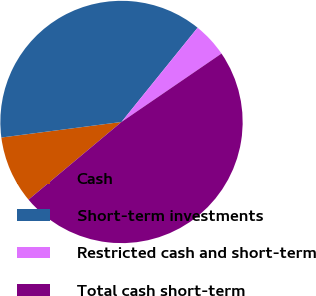Convert chart. <chart><loc_0><loc_0><loc_500><loc_500><pie_chart><fcel>Cash<fcel>Short-term investments<fcel>Restricted cash and short-term<fcel>Total cash short-term<nl><fcel>9.03%<fcel>37.86%<fcel>4.64%<fcel>48.47%<nl></chart> 